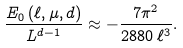Convert formula to latex. <formula><loc_0><loc_0><loc_500><loc_500>\frac { E _ { 0 } \left ( \ell , \mu , d \right ) } { L ^ { d - 1 } } \approx - \frac { 7 \pi ^ { 2 } } { 2 8 8 0 \, \ell ^ { 3 } } .</formula> 